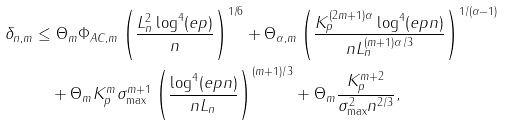<formula> <loc_0><loc_0><loc_500><loc_500>\delta _ { n , m } & \leq \Theta _ { m } \Phi _ { A C , m } \left ( \frac { L _ { n } ^ { 2 } \log ^ { 4 } ( e p ) } { n } \right ) ^ { 1 / 6 } + \Theta _ { \alpha , m } \left ( \frac { K _ { p } ^ { ( 2 m + 1 ) \alpha } \log ^ { 4 } ( e p n ) } { n L _ { n } ^ { ( m + 1 ) \alpha / 3 } } \right ) ^ { 1 / ( \alpha - 1 ) } \\ & \quad + \Theta _ { m } K _ { p } ^ { m } \sigma _ { \max } ^ { m + 1 } \left ( \frac { \log ^ { 4 } ( e p n ) } { n L _ { n } } \right ) ^ { ( m + 1 ) / 3 } + \Theta _ { m } \frac { K _ { p } ^ { m + 2 } } { \sigma _ { \max } ^ { 2 } n ^ { 2 / 3 } } ,</formula> 